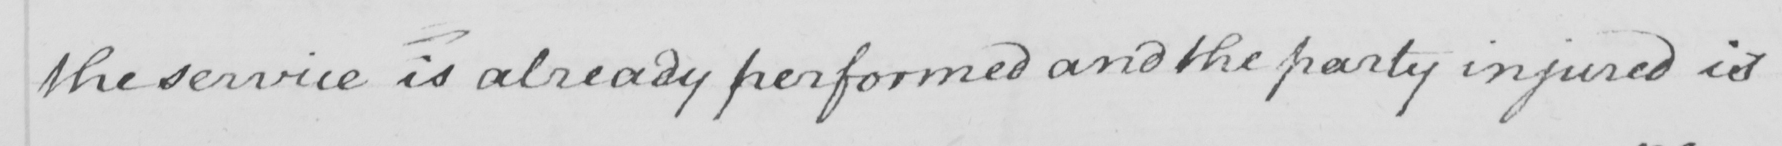Can you tell me what this handwritten text says? the service is already performed and the party injured is 